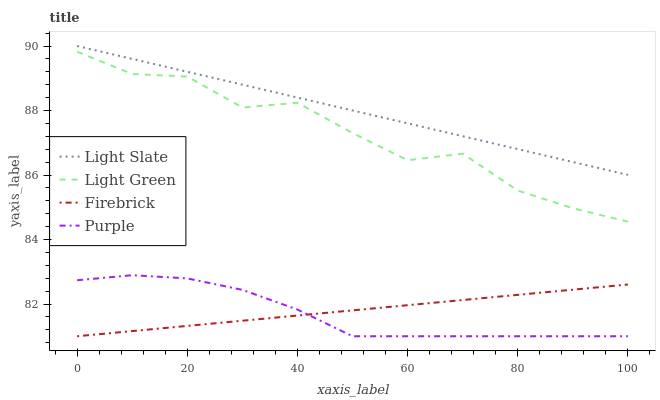Does Purple have the minimum area under the curve?
Answer yes or no. Yes. Does Light Slate have the maximum area under the curve?
Answer yes or no. Yes. Does Firebrick have the minimum area under the curve?
Answer yes or no. No. Does Firebrick have the maximum area under the curve?
Answer yes or no. No. Is Light Slate the smoothest?
Answer yes or no. Yes. Is Light Green the roughest?
Answer yes or no. Yes. Is Purple the smoothest?
Answer yes or no. No. Is Purple the roughest?
Answer yes or no. No. Does Purple have the lowest value?
Answer yes or no. Yes. Does Light Green have the lowest value?
Answer yes or no. No. Does Light Slate have the highest value?
Answer yes or no. Yes. Does Purple have the highest value?
Answer yes or no. No. Is Light Green less than Light Slate?
Answer yes or no. Yes. Is Light Slate greater than Purple?
Answer yes or no. Yes. Does Firebrick intersect Purple?
Answer yes or no. Yes. Is Firebrick less than Purple?
Answer yes or no. No. Is Firebrick greater than Purple?
Answer yes or no. No. Does Light Green intersect Light Slate?
Answer yes or no. No. 